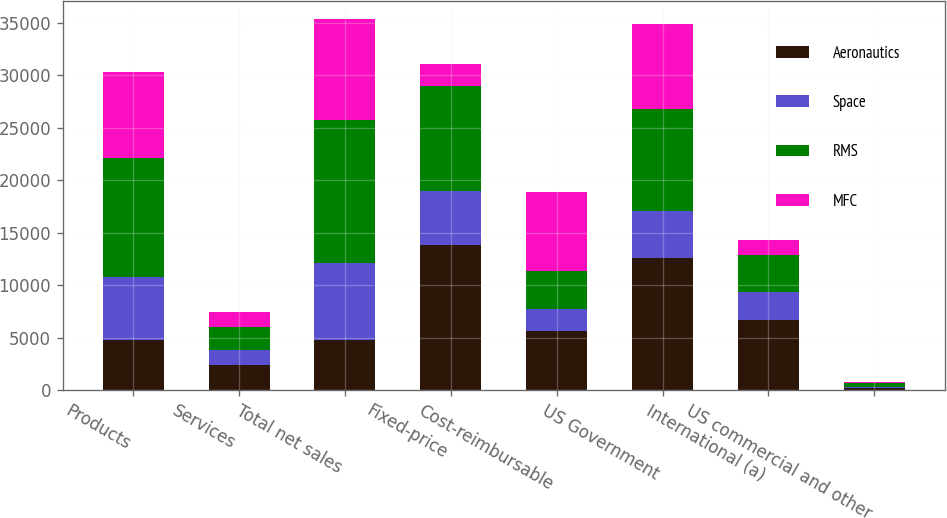<chart> <loc_0><loc_0><loc_500><loc_500><stacked_bar_chart><ecel><fcel>Products<fcel>Services<fcel>Total net sales<fcel>Fixed-price<fcel>Cost-reimbursable<fcel>US Government<fcel>International (a)<fcel>US commercial and other<nl><fcel>Aeronautics<fcel>4784.5<fcel>2429<fcel>4784.5<fcel>13828<fcel>5582<fcel>12609<fcel>6641<fcel>160<nl><fcel>Space<fcel>5940<fcel>1342<fcel>7282<fcel>5102<fcel>2180<fcel>4467<fcel>2672<fcel>143<nl><fcel>RMS<fcel>11398<fcel>2265<fcel>13663<fcel>10059<fcel>3604<fcel>9715<fcel>3575<fcel>373<nl><fcel>MFC<fcel>8183<fcel>1422<fcel>9605<fcel>2058<fcel>7547<fcel>8088<fcel>1446<fcel>71<nl></chart> 